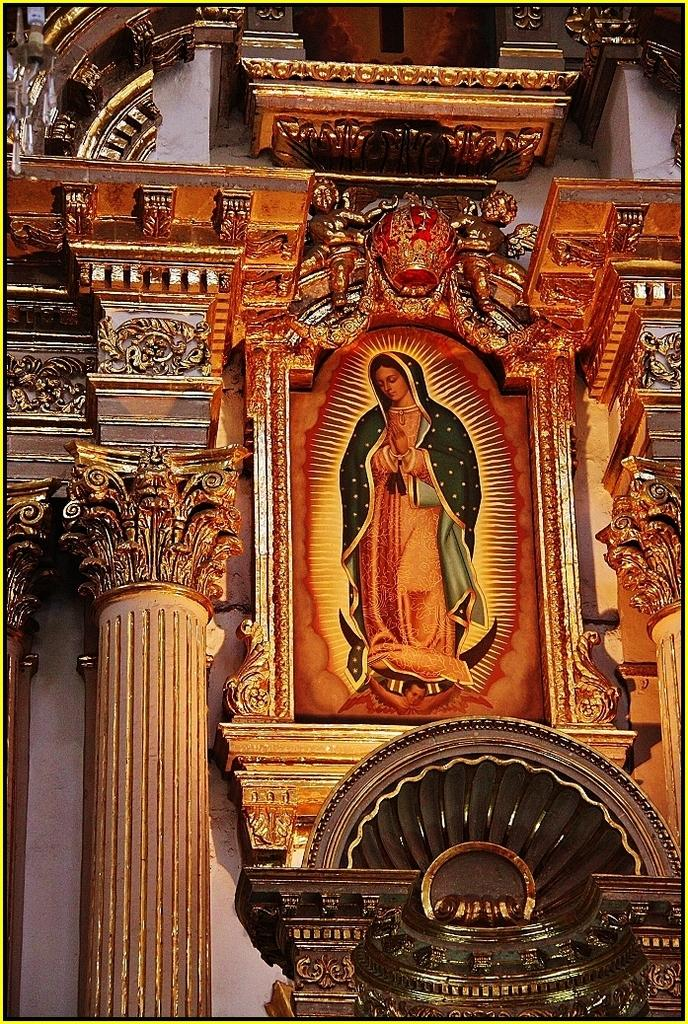What type of location is depicted in the image? The image shows an inner view of a building. What can be seen on the wall in the image? There is a frame on the wall. What is happening inside the frame? A person is standing inside the frame. What architectural features are visible in the image? There are pillars visible in the image. What type of acoustics can be heard in the image? There is no information about the acoustics in the image, as it only shows a visual representation of a building's interior. Can you see the seashore in the image? No, the image does not depict a seashore; it shows an inner view of a building. 